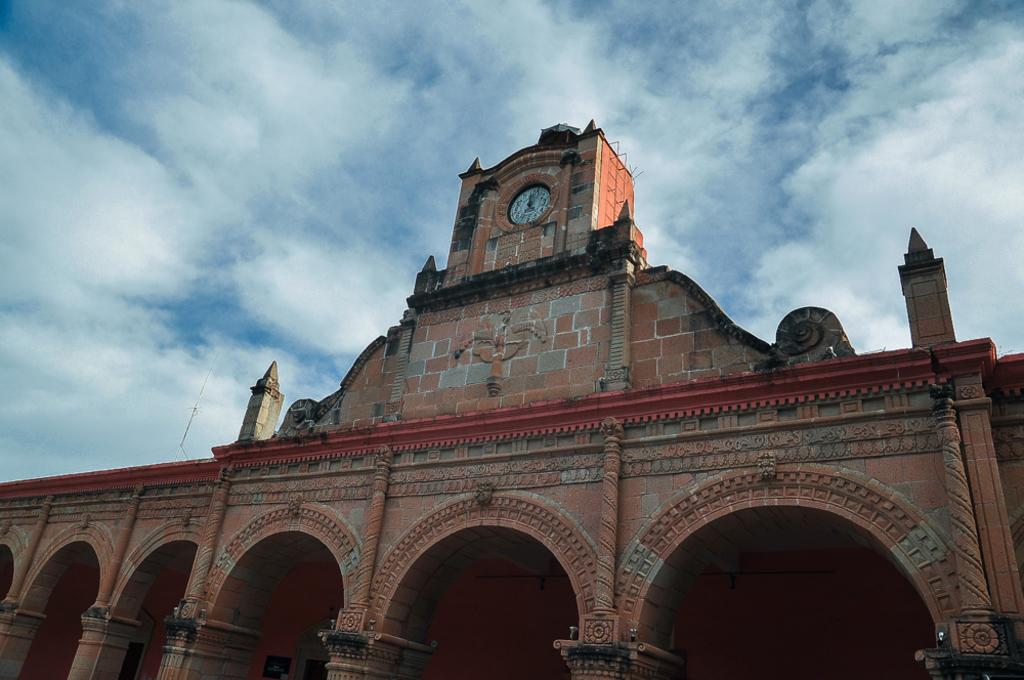What is the main structure in the front of the image? There is a building in the front of the image. What feature can be seen on the building? There is a clock on the wall of the building. What can be seen in the background of the image? Clouds and the sky are visible in the background of the image. What type of fowl can be seen walking on the roof of the building in the image? There are no fowl visible on the roof of the building in the image. 